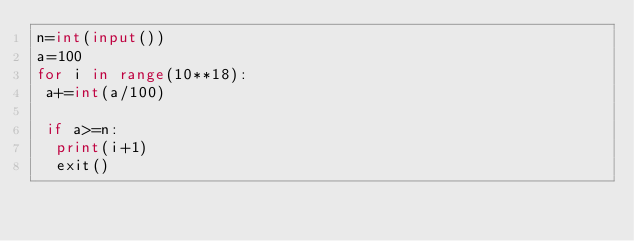<code> <loc_0><loc_0><loc_500><loc_500><_Python_>n=int(input())
a=100
for i in range(10**18):
 a+=int(a/100)

 if a>=n:
  print(i+1)
  exit()</code> 